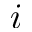Convert formula to latex. <formula><loc_0><loc_0><loc_500><loc_500>i</formula> 